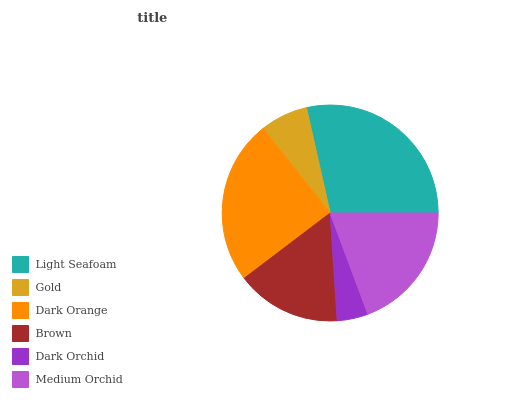Is Dark Orchid the minimum?
Answer yes or no. Yes. Is Light Seafoam the maximum?
Answer yes or no. Yes. Is Gold the minimum?
Answer yes or no. No. Is Gold the maximum?
Answer yes or no. No. Is Light Seafoam greater than Gold?
Answer yes or no. Yes. Is Gold less than Light Seafoam?
Answer yes or no. Yes. Is Gold greater than Light Seafoam?
Answer yes or no. No. Is Light Seafoam less than Gold?
Answer yes or no. No. Is Medium Orchid the high median?
Answer yes or no. Yes. Is Brown the low median?
Answer yes or no. Yes. Is Brown the high median?
Answer yes or no. No. Is Gold the low median?
Answer yes or no. No. 